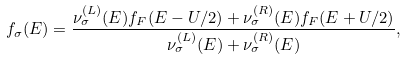<formula> <loc_0><loc_0><loc_500><loc_500>f _ { \sigma } ( E ) = \frac { \nu ^ { ( L ) } _ { \sigma } ( E ) f _ { F } ( E - U / 2 ) + \nu ^ { ( R ) } _ { \sigma } ( E ) f _ { F } ( E + U / 2 ) } { \nu ^ { ( L ) } _ { \sigma } ( E ) + \nu ^ { ( R ) } _ { \sigma } ( E ) } ,</formula> 